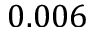<formula> <loc_0><loc_0><loc_500><loc_500>0 . 0 0 6</formula> 